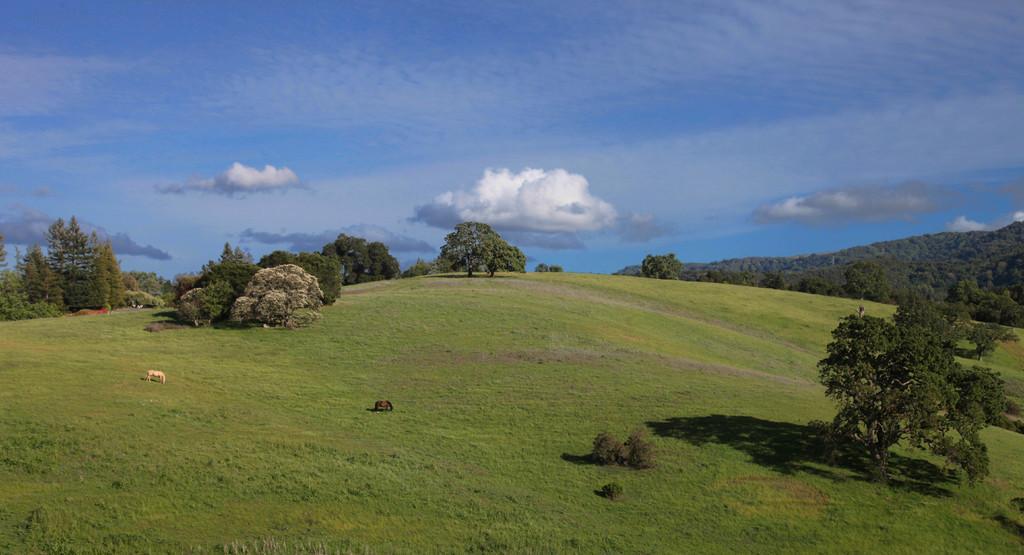How would you summarize this image in a sentence or two? In the image there are two horses standing on the grassland, in the back there are trees and above its sky with clouds. 